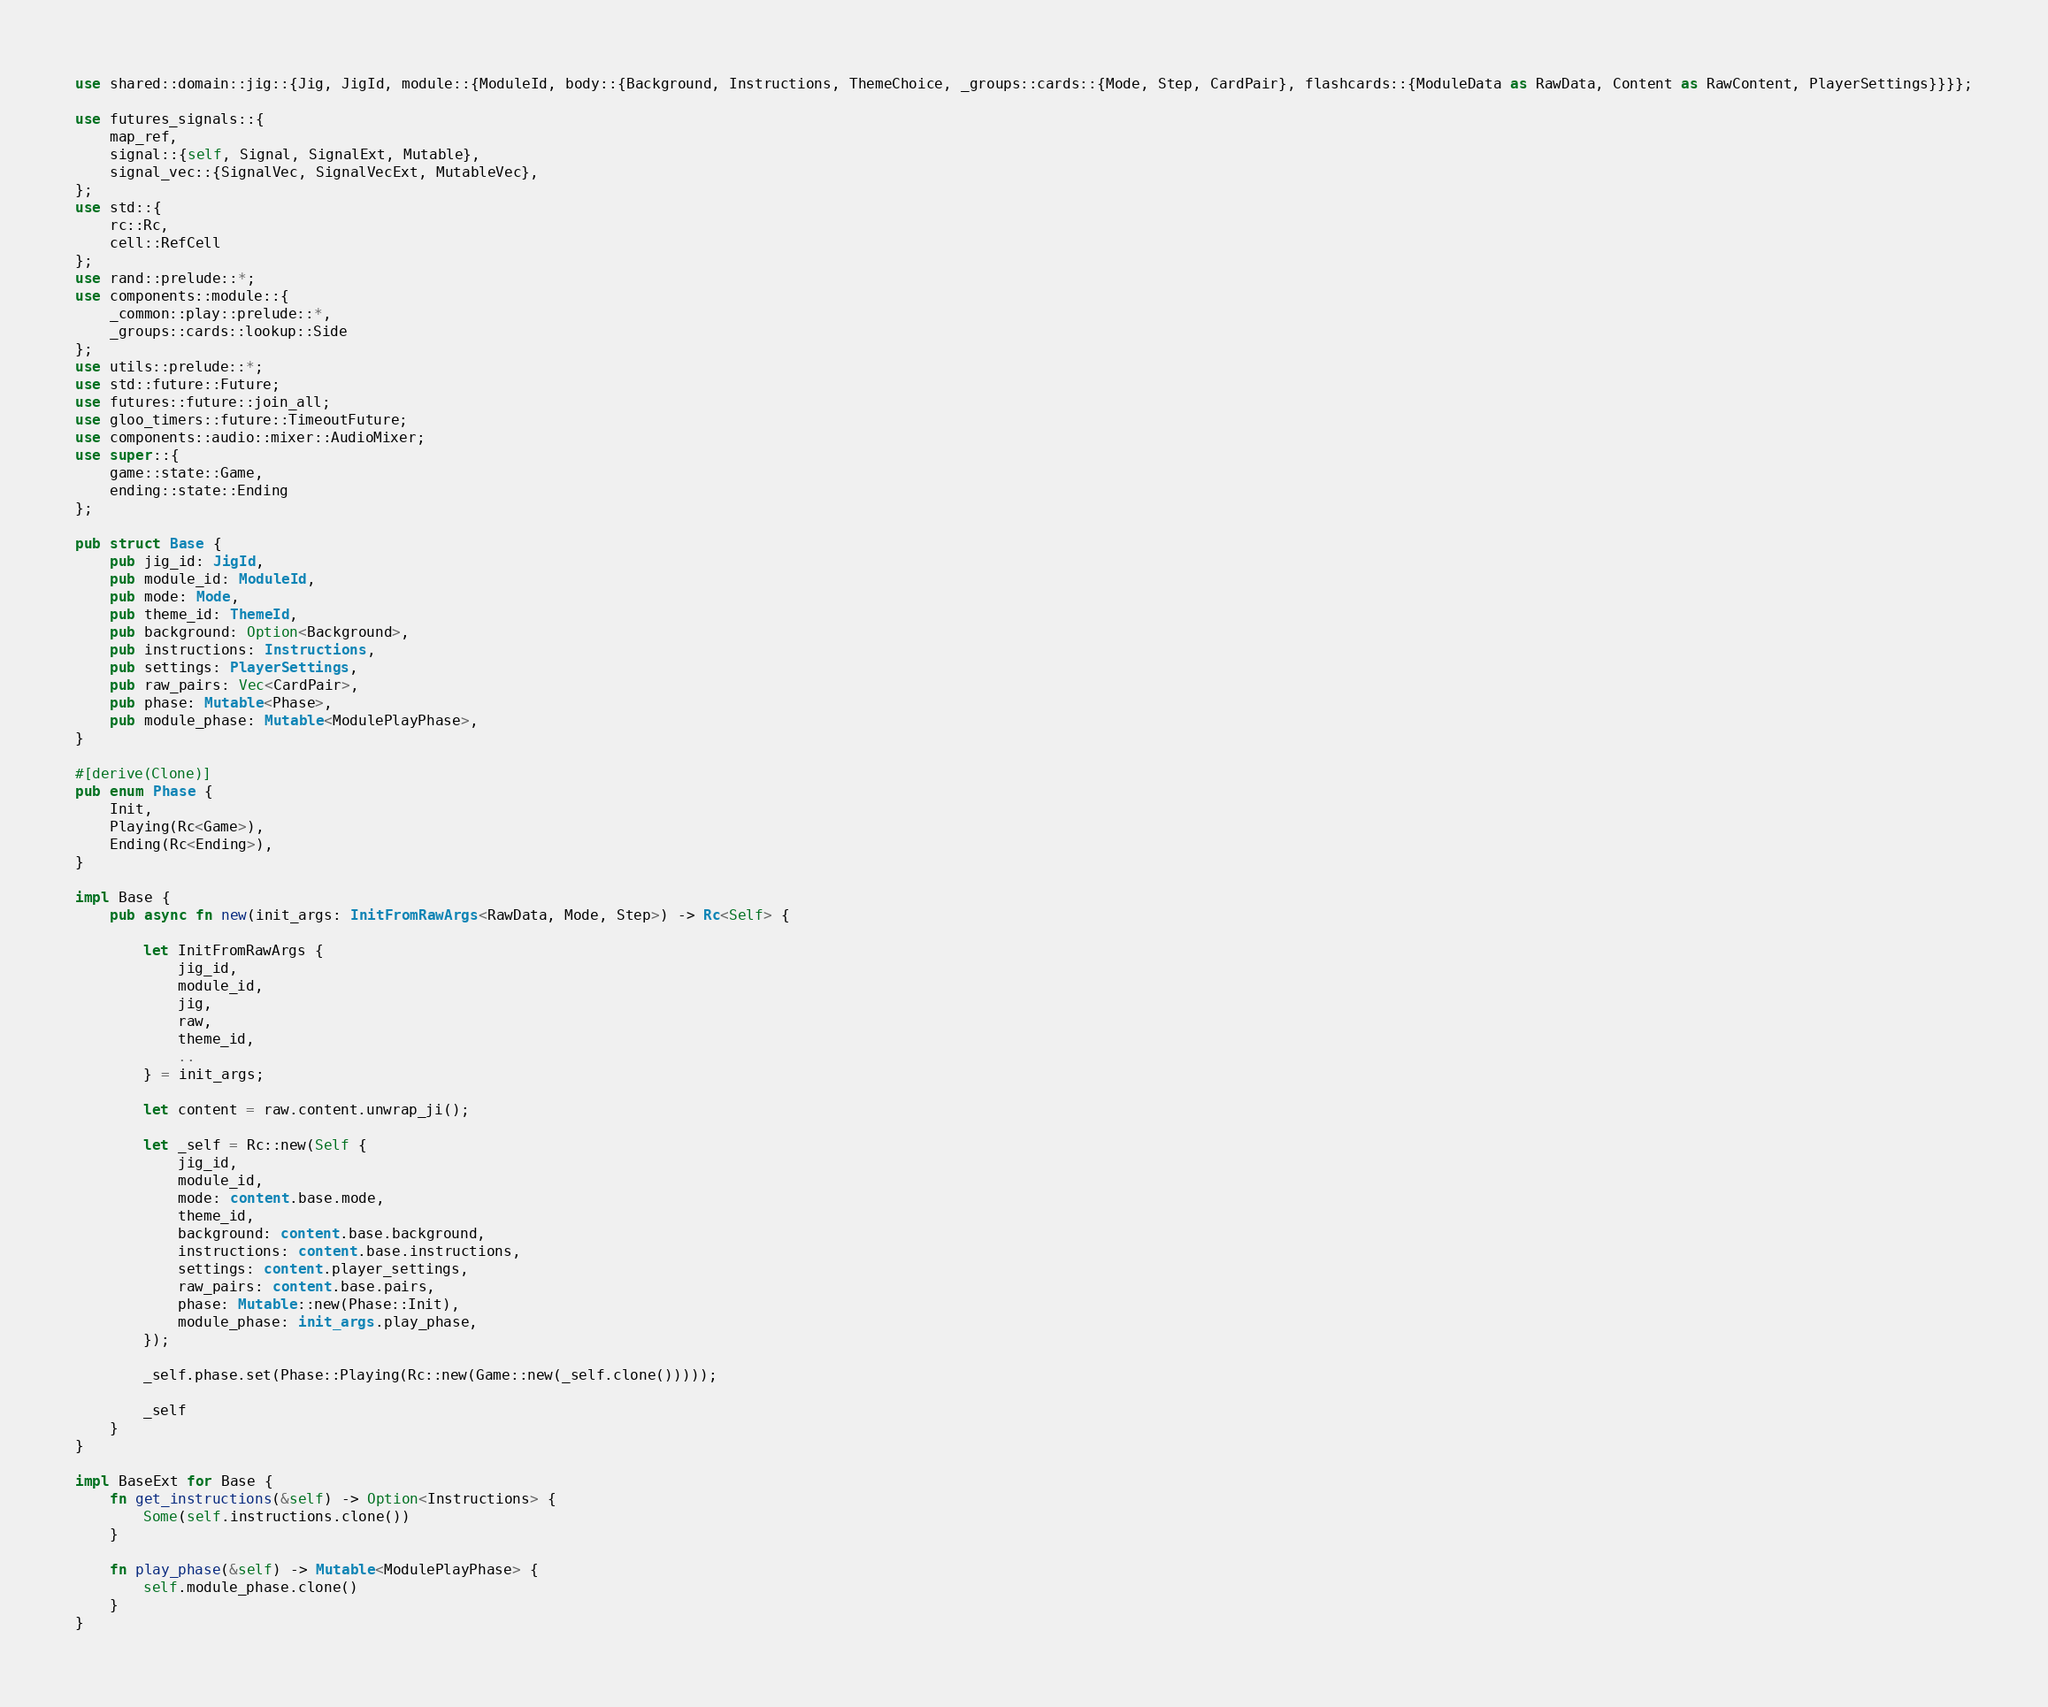<code> <loc_0><loc_0><loc_500><loc_500><_Rust_>use shared::domain::jig::{Jig, JigId, module::{ModuleId, body::{Background, Instructions, ThemeChoice, _groups::cards::{Mode, Step, CardPair}, flashcards::{ModuleData as RawData, Content as RawContent, PlayerSettings}}}};

use futures_signals::{
    map_ref,
    signal::{self, Signal, SignalExt, Mutable},
    signal_vec::{SignalVec, SignalVecExt, MutableVec},
};
use std::{
    rc::Rc,
    cell::RefCell
};
use rand::prelude::*;
use components::module::{
    _common::play::prelude::*,
    _groups::cards::lookup::Side
};
use utils::prelude::*;
use std::future::Future;
use futures::future::join_all;
use gloo_timers::future::TimeoutFuture;
use components::audio::mixer::AudioMixer;
use super::{
    game::state::Game,
    ending::state::Ending
};

pub struct Base {
    pub jig_id: JigId,
    pub module_id: ModuleId,
    pub mode: Mode,
    pub theme_id: ThemeId,
    pub background: Option<Background>,
    pub instructions: Instructions,
    pub settings: PlayerSettings,
    pub raw_pairs: Vec<CardPair>,
    pub phase: Mutable<Phase>,
    pub module_phase: Mutable<ModulePlayPhase>,
}

#[derive(Clone)]
pub enum Phase {
    Init,
    Playing(Rc<Game>),
    Ending(Rc<Ending>), 
}

impl Base {
    pub async fn new(init_args: InitFromRawArgs<RawData, Mode, Step>) -> Rc<Self> {

        let InitFromRawArgs {
            jig_id,
            module_id,
            jig,
            raw,
            theme_id,
            ..
        } = init_args;

        let content = raw.content.unwrap_ji();

        let _self = Rc::new(Self {
            jig_id,
            module_id,
            mode: content.base.mode,
            theme_id,
            background: content.base.background,
            instructions: content.base.instructions,
            settings: content.player_settings,
            raw_pairs: content.base.pairs,
            phase: Mutable::new(Phase::Init),
            module_phase: init_args.play_phase,
        });

        _self.phase.set(Phase::Playing(Rc::new(Game::new(_self.clone()))));

        _self
    }
}

impl BaseExt for Base {
    fn get_instructions(&self) -> Option<Instructions> {
        Some(self.instructions.clone())
    }

    fn play_phase(&self) -> Mutable<ModulePlayPhase> {
        self.module_phase.clone()
    }
}
</code> 